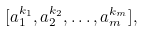<formula> <loc_0><loc_0><loc_500><loc_500>[ a _ { 1 } ^ { k _ { 1 } } , a _ { 2 } ^ { k _ { 2 } } , \dots , a _ { m } ^ { k _ { m } } ] ,</formula> 